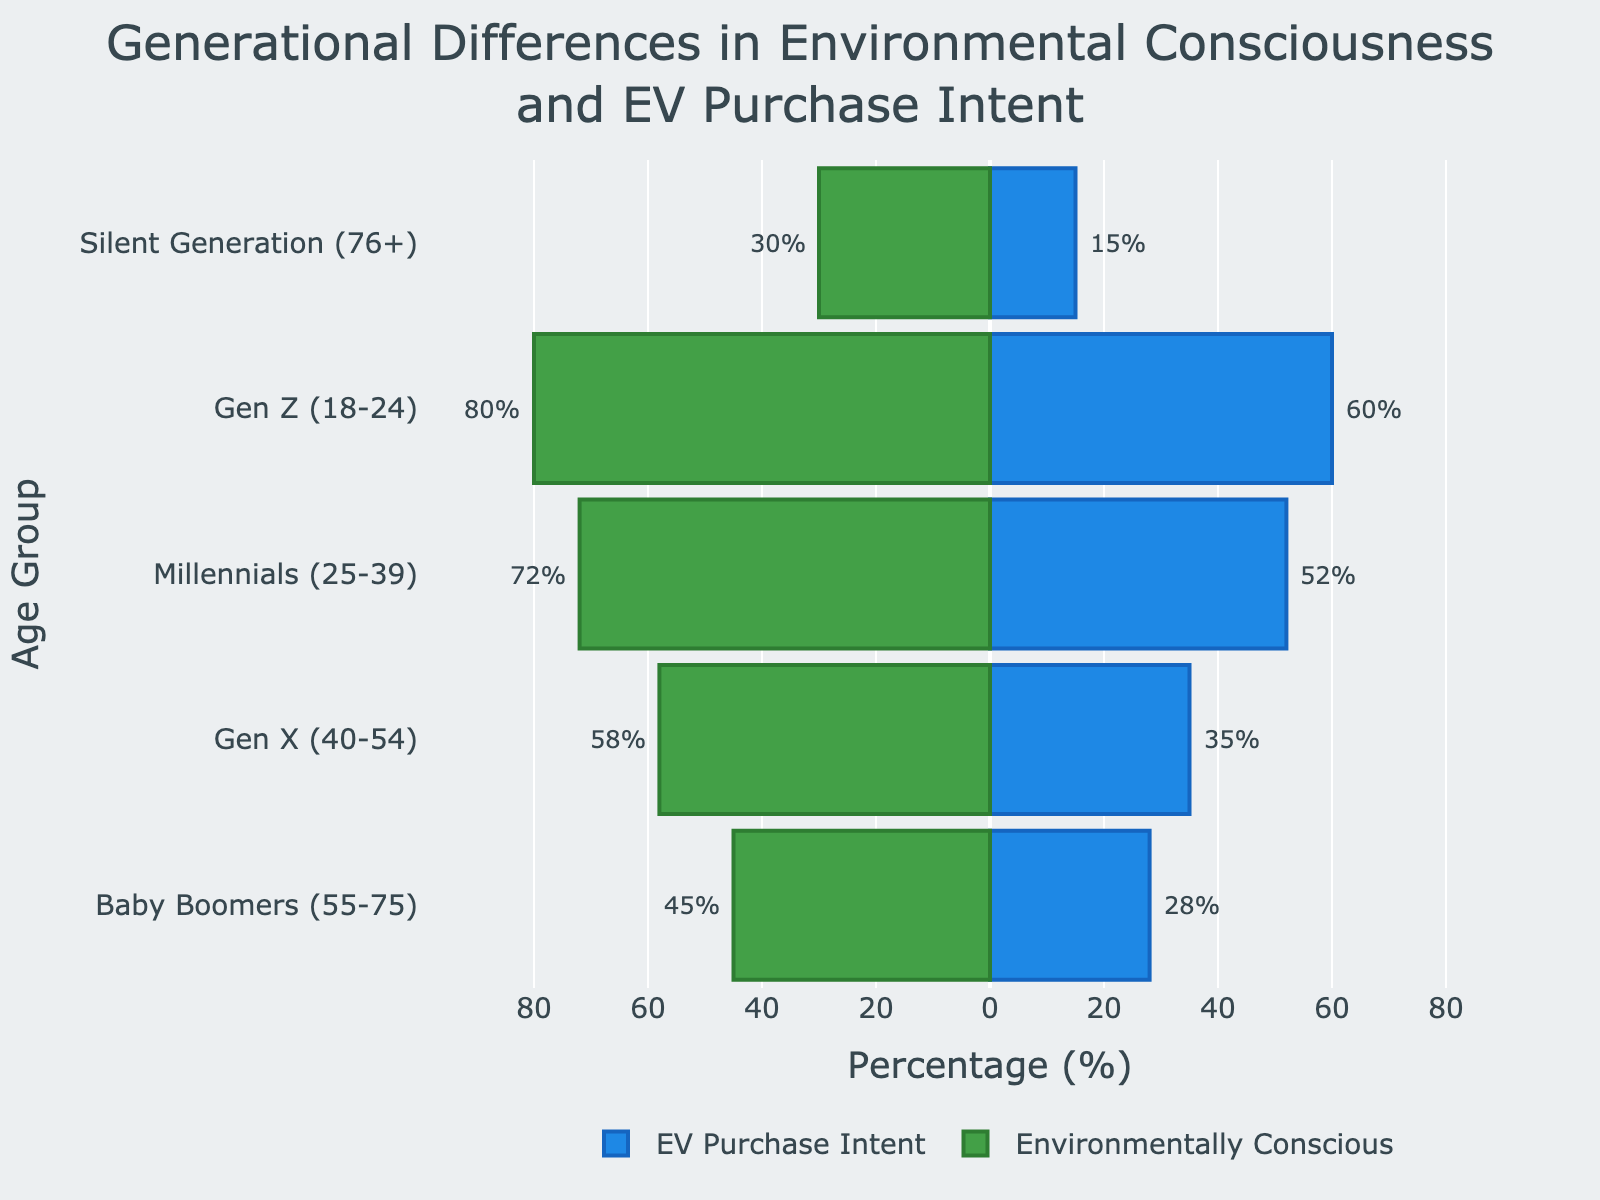Which age group has the highest percentage of environmentally conscious individuals? The figure shows that Gen Z has the highest percentage of environmentally conscious individuals at 80%.
Answer: Gen Z What is the percentage difference in EV purchase intent between Millennials and Gen X? Millennials have a 52% EV purchase intent, and Gen X has 35%. The difference is 52% - 35% = 17%.
Answer: 17% Which age group shows the smallest gap between environmental consciousness and EV purchase intent? The Baby Boomers have 45% environmentally conscious and 28% EV purchase intent, making the gap 45 - 28 = 17%. Gen X has a gap of 58 - 35 = 23%. Millennials have a gap of 72 - 52 = 20%, and Gen Z has 80 - 60 = 20%. The Silent Generation has a gap of 30 - 15 = 15%. The smallest gap is 15% for the Silent Generation.
Answer: Silent Generation Among the age groups, who has the lowest EV purchase intent percentage? The figure shows that the Silent Generation has the lowest EV purchase intent at 15%.
Answer: Silent Generation Calculate the average percentage of environmentally conscious individuals across all age groups. Summing the percentages: 45 + 58 + 72 + 80 + 30 = 285. Dividing by 5 age groups results in 285 / 5 = 57%.
Answer: 57% How does the percentage of environmentally conscious Gen X compare to Millennials? The figure indicates that 58% of Gen X is environmentally conscious, while 72% of Millennials are. Gen X is less environmentally conscious by 72% - 58% = 14%.
Answer: 14% less Identify the age group with the greatest disparity between environmental consciousness and EV purchase intent. Calculate the disparity for each group: Baby Boomers, 45 - 28 = 17; Gen X, 58 - 35 = 23; Millennials, 72 - 52 = 20; Gen Z, 80 - 60 = 20; Silent Generation, 30 - 15 = 15. The greatest disparity is for Gen X with 23%.
Answer: Gen X Compare the EV purchase intent between Millennials and Baby Boomers. The figure shows Millennials have a 52% EV purchase intent and Baby Boomers have 28%, indicating Millennials have a higher intent by 52% - 28% = 24%.
Answer: 24% higher What percentage of environmentally conscious individuals do Baby Boomers and the Silent Generation have combined? Adding their percentages: 45% (Baby Boomers) + 30% (Silent Generation) = 75%.
Answer: 75% Which two age groups have the closest percentages of EV purchase intent, and what are those percentages? The figure shows Baby Boomers have 28%, Gen X has 35%, Millennials have 52%, Gen Z has 60%, and Silent Generation has 15%. The closest percentages are 28% and 35% of Baby Boomers and Gen X, respectively. The difference is 35 - 28 = 7%.
Answer: Baby Boomers and Gen X, 28% and 35% 